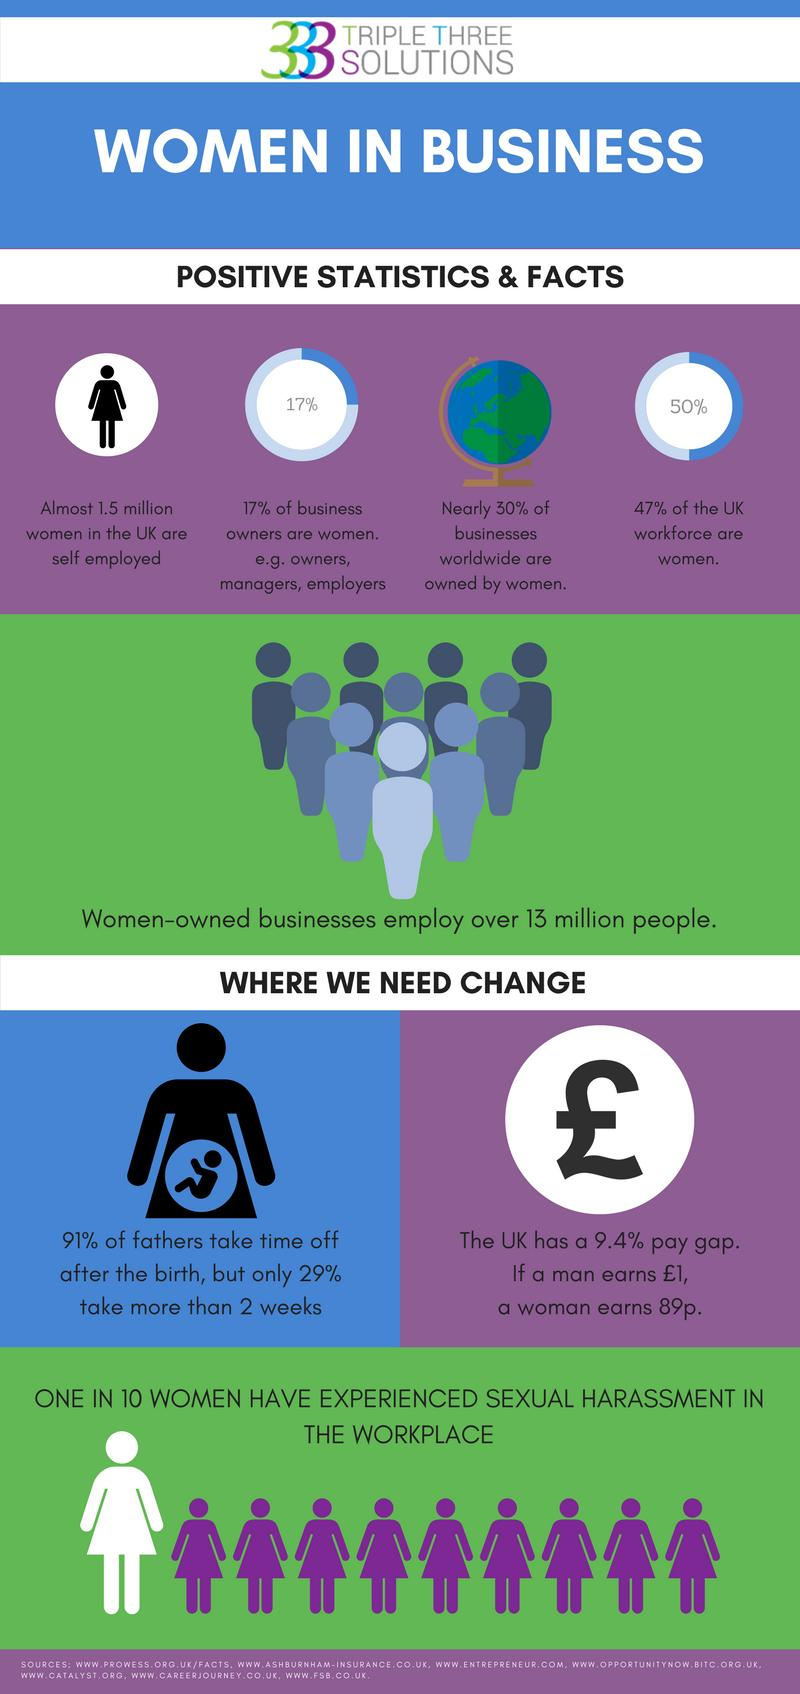Give some essential details in this illustration. According to recent statistics, approximately 53% of the UK workforce are not women. Out of 10, 9 women have never experienced sexual harassment in the workplace. According to a recent study, a staggering 83% of business owners are not women, representing a significant gender disparity in the business world. 